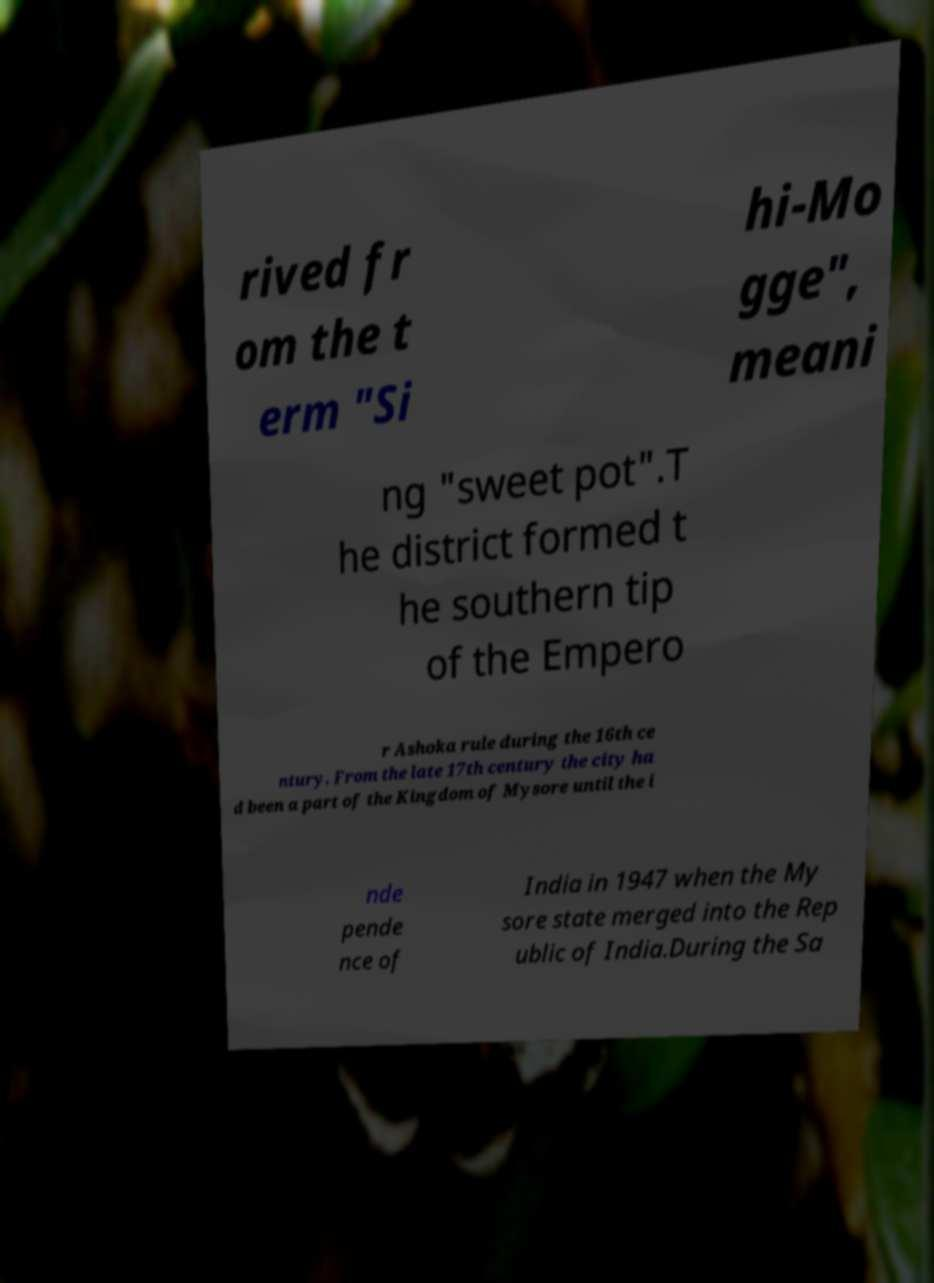I need the written content from this picture converted into text. Can you do that? rived fr om the t erm "Si hi-Mo gge", meani ng "sweet pot".T he district formed t he southern tip of the Empero r Ashoka rule during the 16th ce ntury. From the late 17th century the city ha d been a part of the Kingdom of Mysore until the i nde pende nce of India in 1947 when the My sore state merged into the Rep ublic of India.During the Sa 